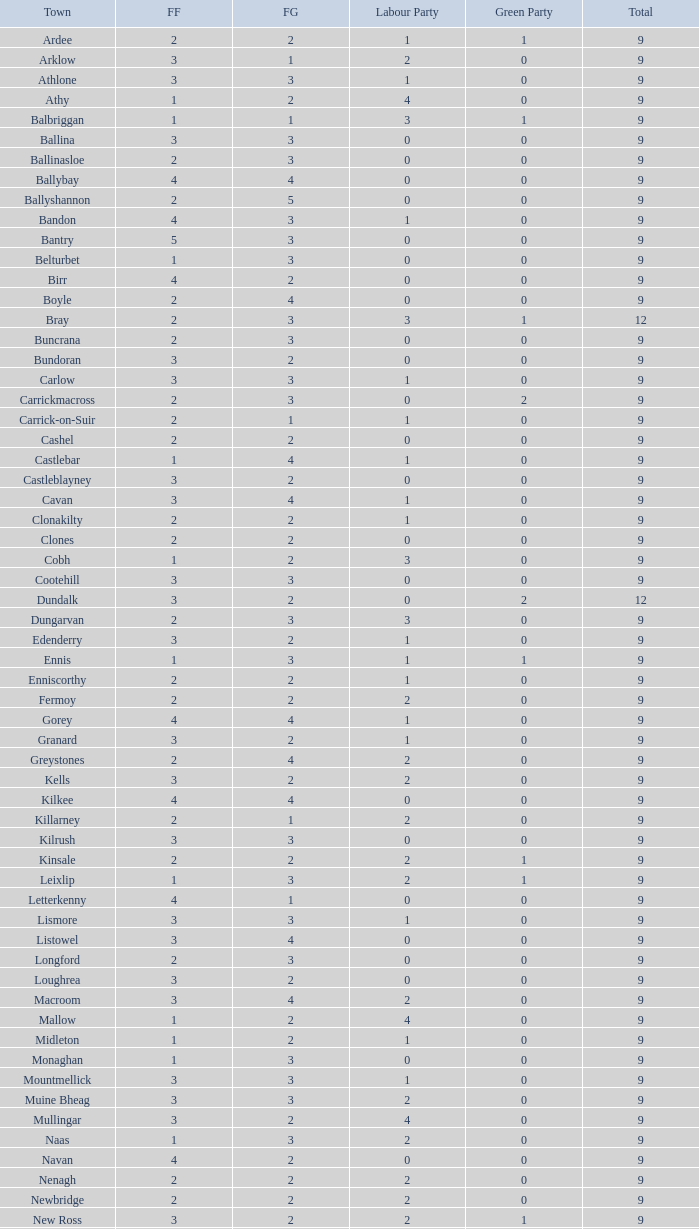How many are in the Green Party with a Fine Gael of less than 4 and a Fianna Fail of less than 2 in Athy? 0.0. 